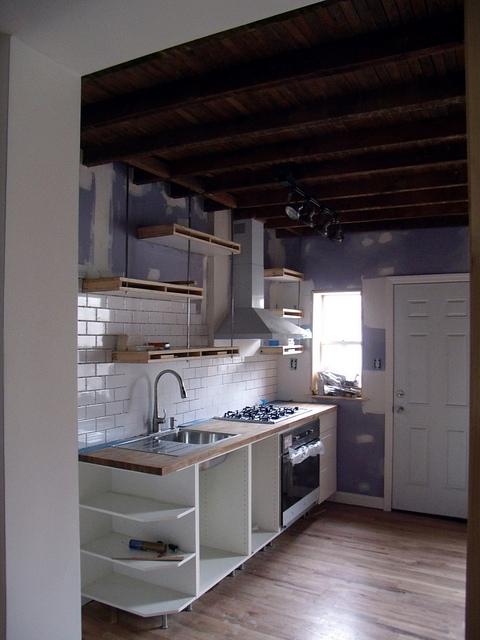Is the door broken?
Short answer required. No. What is stacked on the bottom shelf of the cabinet?
Concise answer only. Nothing. Is this kitchen open?
Be succinct. Yes. Is this a restaurant?
Keep it brief. No. Is this kitchen mostly empty?
Be succinct. Yes. What room is this?
Keep it brief. Kitchen. Are the counters made of wood?
Concise answer only. Yes. What is the backsplash made of?
Short answer required. Tile. 